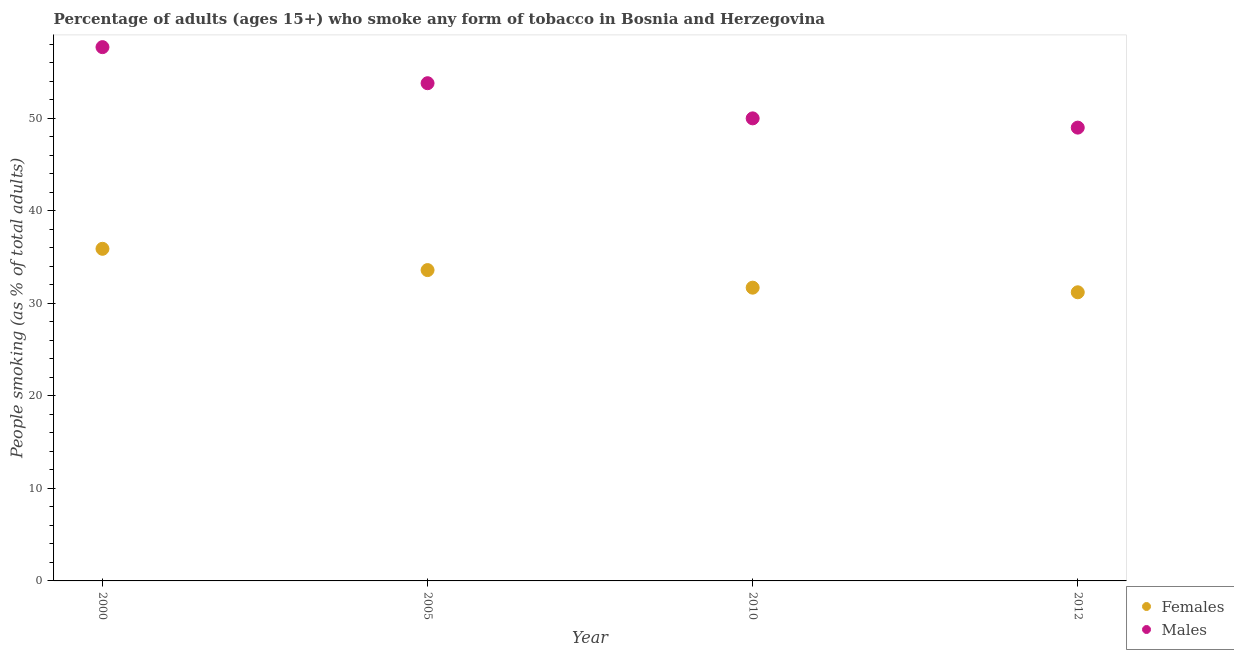Is the number of dotlines equal to the number of legend labels?
Make the answer very short. Yes. What is the percentage of females who smoke in 2010?
Offer a terse response. 31.7. Across all years, what is the maximum percentage of males who smoke?
Ensure brevity in your answer.  57.7. Across all years, what is the minimum percentage of females who smoke?
Keep it short and to the point. 31.2. In which year was the percentage of males who smoke minimum?
Your response must be concise. 2012. What is the total percentage of females who smoke in the graph?
Your answer should be compact. 132.4. What is the average percentage of females who smoke per year?
Ensure brevity in your answer.  33.1. In the year 2012, what is the difference between the percentage of females who smoke and percentage of males who smoke?
Give a very brief answer. -17.8. In how many years, is the percentage of males who smoke greater than 8 %?
Make the answer very short. 4. What is the ratio of the percentage of males who smoke in 2005 to that in 2010?
Make the answer very short. 1.08. What is the difference between the highest and the second highest percentage of females who smoke?
Give a very brief answer. 2.3. What is the difference between the highest and the lowest percentage of males who smoke?
Your answer should be very brief. 8.7. In how many years, is the percentage of males who smoke greater than the average percentage of males who smoke taken over all years?
Keep it short and to the point. 2. Is the percentage of females who smoke strictly less than the percentage of males who smoke over the years?
Your answer should be very brief. Yes. Where does the legend appear in the graph?
Make the answer very short. Bottom right. How are the legend labels stacked?
Offer a terse response. Vertical. What is the title of the graph?
Ensure brevity in your answer.  Percentage of adults (ages 15+) who smoke any form of tobacco in Bosnia and Herzegovina. Does "Old" appear as one of the legend labels in the graph?
Your answer should be compact. No. What is the label or title of the Y-axis?
Ensure brevity in your answer.  People smoking (as % of total adults). What is the People smoking (as % of total adults) of Females in 2000?
Your answer should be compact. 35.9. What is the People smoking (as % of total adults) of Males in 2000?
Offer a terse response. 57.7. What is the People smoking (as % of total adults) of Females in 2005?
Make the answer very short. 33.6. What is the People smoking (as % of total adults) of Males in 2005?
Keep it short and to the point. 53.8. What is the People smoking (as % of total adults) in Females in 2010?
Provide a short and direct response. 31.7. What is the People smoking (as % of total adults) in Females in 2012?
Give a very brief answer. 31.2. Across all years, what is the maximum People smoking (as % of total adults) in Females?
Offer a terse response. 35.9. Across all years, what is the maximum People smoking (as % of total adults) of Males?
Give a very brief answer. 57.7. Across all years, what is the minimum People smoking (as % of total adults) in Females?
Offer a very short reply. 31.2. Across all years, what is the minimum People smoking (as % of total adults) of Males?
Make the answer very short. 49. What is the total People smoking (as % of total adults) in Females in the graph?
Ensure brevity in your answer.  132.4. What is the total People smoking (as % of total adults) of Males in the graph?
Keep it short and to the point. 210.5. What is the difference between the People smoking (as % of total adults) of Females in 2000 and that in 2010?
Ensure brevity in your answer.  4.2. What is the difference between the People smoking (as % of total adults) of Males in 2000 and that in 2010?
Provide a succinct answer. 7.7. What is the difference between the People smoking (as % of total adults) in Females in 2000 and that in 2012?
Give a very brief answer. 4.7. What is the difference between the People smoking (as % of total adults) in Females in 2005 and that in 2010?
Provide a succinct answer. 1.9. What is the difference between the People smoking (as % of total adults) in Males in 2005 and that in 2012?
Your answer should be compact. 4.8. What is the difference between the People smoking (as % of total adults) of Females in 2000 and the People smoking (as % of total adults) of Males in 2005?
Provide a short and direct response. -17.9. What is the difference between the People smoking (as % of total adults) in Females in 2000 and the People smoking (as % of total adults) in Males in 2010?
Your answer should be compact. -14.1. What is the difference between the People smoking (as % of total adults) of Females in 2005 and the People smoking (as % of total adults) of Males in 2010?
Provide a succinct answer. -16.4. What is the difference between the People smoking (as % of total adults) in Females in 2005 and the People smoking (as % of total adults) in Males in 2012?
Ensure brevity in your answer.  -15.4. What is the difference between the People smoking (as % of total adults) of Females in 2010 and the People smoking (as % of total adults) of Males in 2012?
Your response must be concise. -17.3. What is the average People smoking (as % of total adults) in Females per year?
Ensure brevity in your answer.  33.1. What is the average People smoking (as % of total adults) in Males per year?
Your answer should be compact. 52.62. In the year 2000, what is the difference between the People smoking (as % of total adults) in Females and People smoking (as % of total adults) in Males?
Provide a short and direct response. -21.8. In the year 2005, what is the difference between the People smoking (as % of total adults) in Females and People smoking (as % of total adults) in Males?
Provide a short and direct response. -20.2. In the year 2010, what is the difference between the People smoking (as % of total adults) in Females and People smoking (as % of total adults) in Males?
Your answer should be very brief. -18.3. In the year 2012, what is the difference between the People smoking (as % of total adults) in Females and People smoking (as % of total adults) in Males?
Make the answer very short. -17.8. What is the ratio of the People smoking (as % of total adults) in Females in 2000 to that in 2005?
Your answer should be compact. 1.07. What is the ratio of the People smoking (as % of total adults) in Males in 2000 to that in 2005?
Provide a short and direct response. 1.07. What is the ratio of the People smoking (as % of total adults) in Females in 2000 to that in 2010?
Ensure brevity in your answer.  1.13. What is the ratio of the People smoking (as % of total adults) of Males in 2000 to that in 2010?
Make the answer very short. 1.15. What is the ratio of the People smoking (as % of total adults) in Females in 2000 to that in 2012?
Ensure brevity in your answer.  1.15. What is the ratio of the People smoking (as % of total adults) in Males in 2000 to that in 2012?
Ensure brevity in your answer.  1.18. What is the ratio of the People smoking (as % of total adults) in Females in 2005 to that in 2010?
Your answer should be compact. 1.06. What is the ratio of the People smoking (as % of total adults) in Males in 2005 to that in 2010?
Provide a short and direct response. 1.08. What is the ratio of the People smoking (as % of total adults) of Females in 2005 to that in 2012?
Provide a succinct answer. 1.08. What is the ratio of the People smoking (as % of total adults) in Males in 2005 to that in 2012?
Your response must be concise. 1.1. What is the ratio of the People smoking (as % of total adults) of Females in 2010 to that in 2012?
Offer a very short reply. 1.02. What is the ratio of the People smoking (as % of total adults) of Males in 2010 to that in 2012?
Ensure brevity in your answer.  1.02. What is the difference between the highest and the second highest People smoking (as % of total adults) of Females?
Your response must be concise. 2.3. What is the difference between the highest and the second highest People smoking (as % of total adults) of Males?
Your answer should be compact. 3.9. What is the difference between the highest and the lowest People smoking (as % of total adults) of Males?
Offer a terse response. 8.7. 